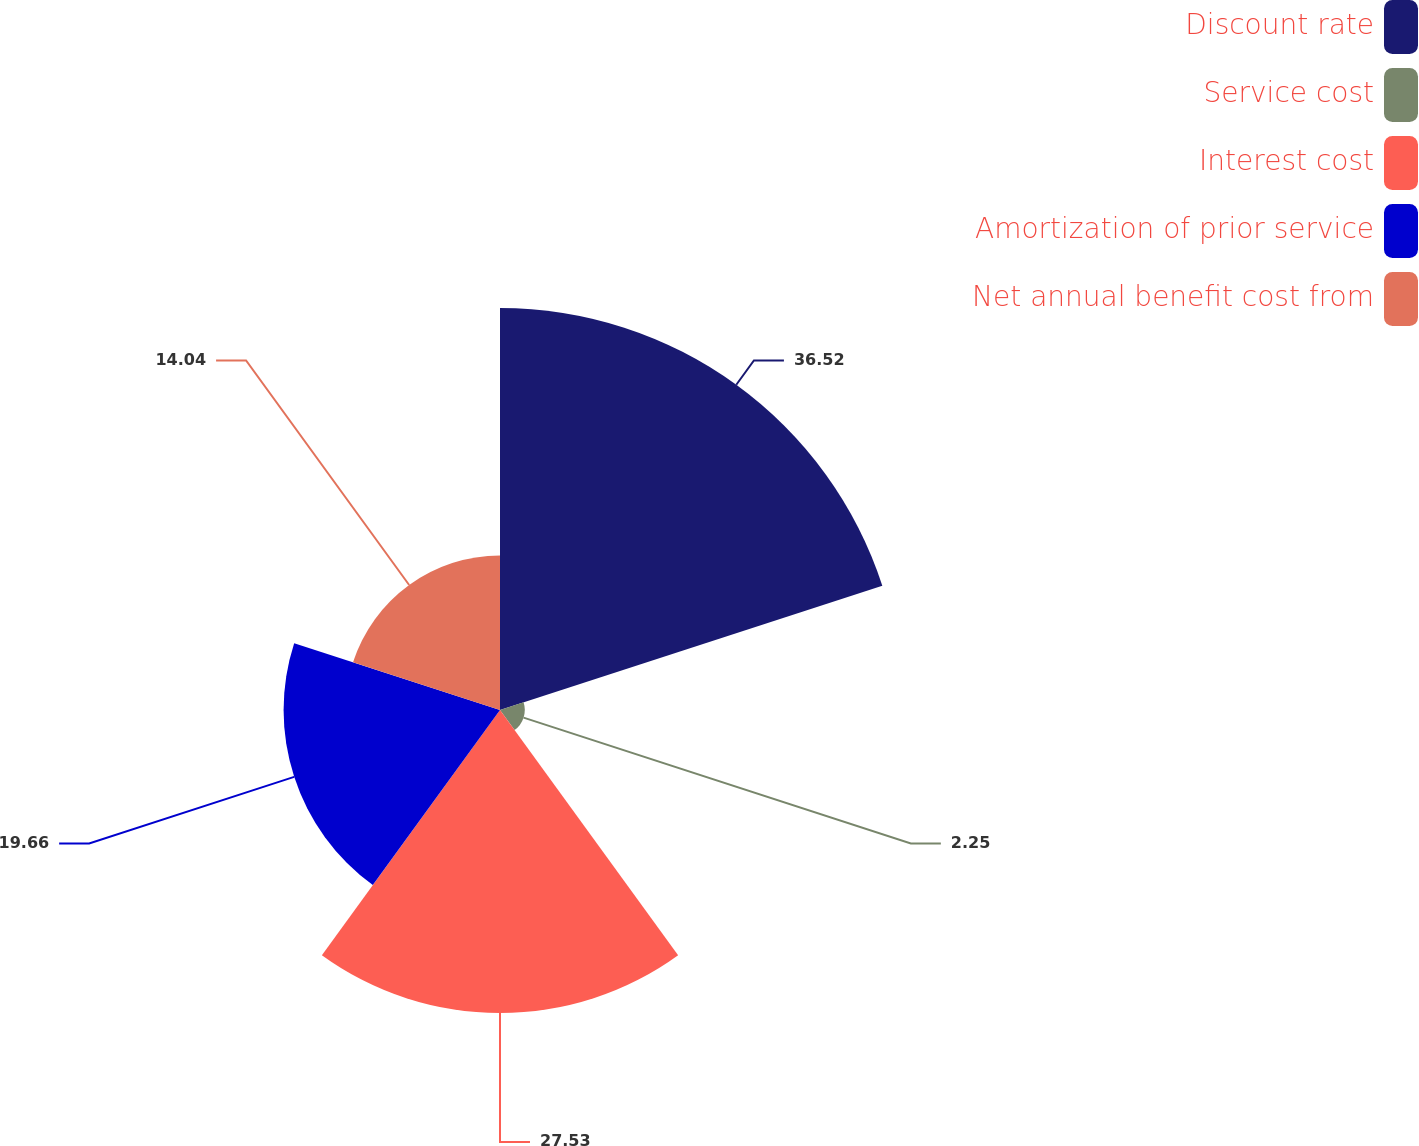Convert chart to OTSL. <chart><loc_0><loc_0><loc_500><loc_500><pie_chart><fcel>Discount rate<fcel>Service cost<fcel>Interest cost<fcel>Amortization of prior service<fcel>Net annual benefit cost from<nl><fcel>36.52%<fcel>2.25%<fcel>27.53%<fcel>19.66%<fcel>14.04%<nl></chart> 